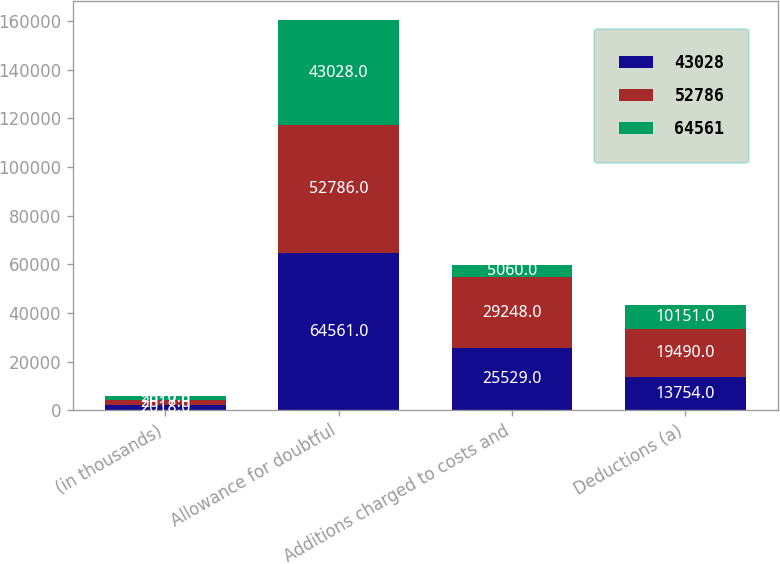Convert chart. <chart><loc_0><loc_0><loc_500><loc_500><stacked_bar_chart><ecel><fcel>(in thousands)<fcel>Allowance for doubtful<fcel>Additions charged to costs and<fcel>Deductions (a)<nl><fcel>43028<fcel>2018<fcel>64561<fcel>25529<fcel>13754<nl><fcel>52786<fcel>2017<fcel>52786<fcel>29248<fcel>19490<nl><fcel>64561<fcel>2016<fcel>43028<fcel>5060<fcel>10151<nl></chart> 